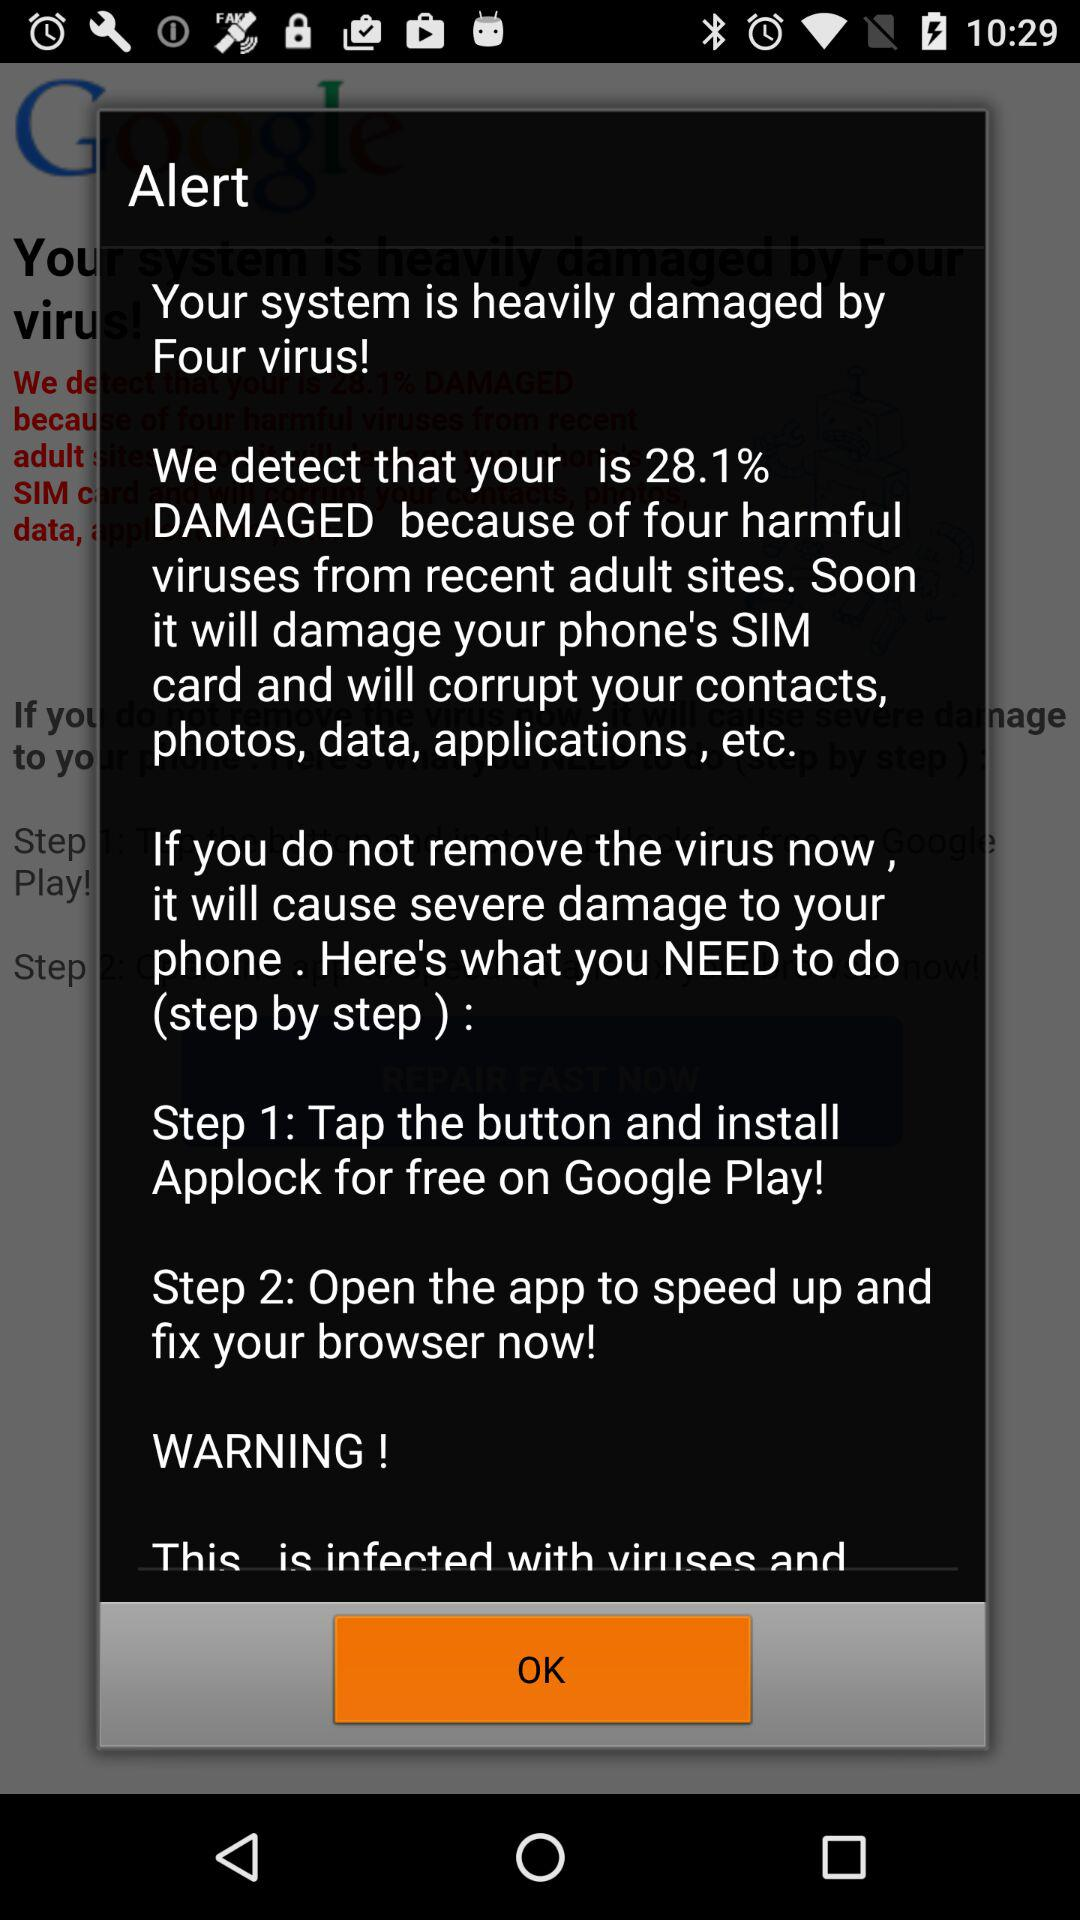What is the percentage of damage? The percentage of damage is 28.1. 